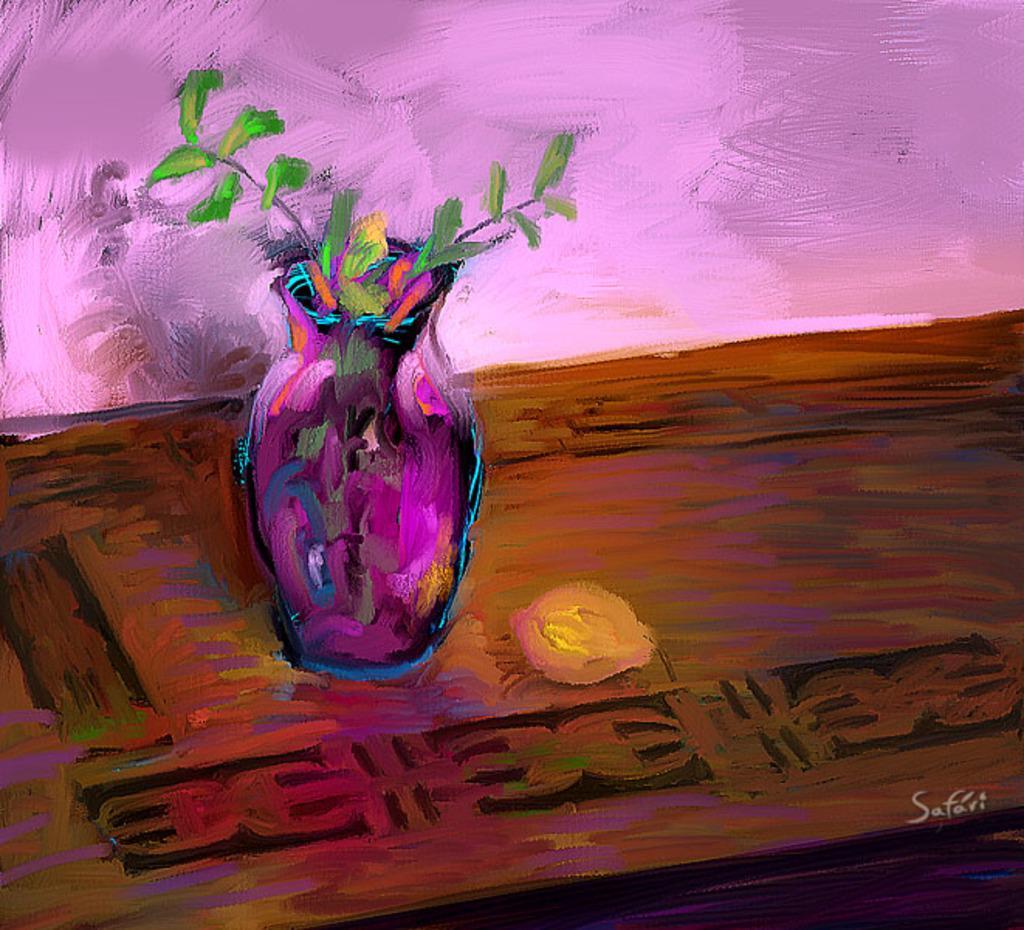In one or two sentences, can you explain what this image depicts? In this picture I can see there is a painting and there is a wooden table and there is a flower vase with a few flowers in it. There is a wall in the backdrop. 